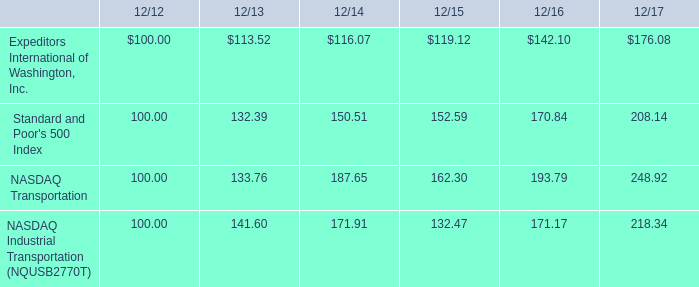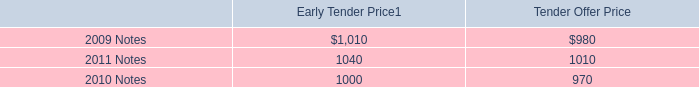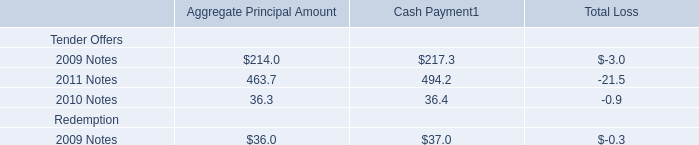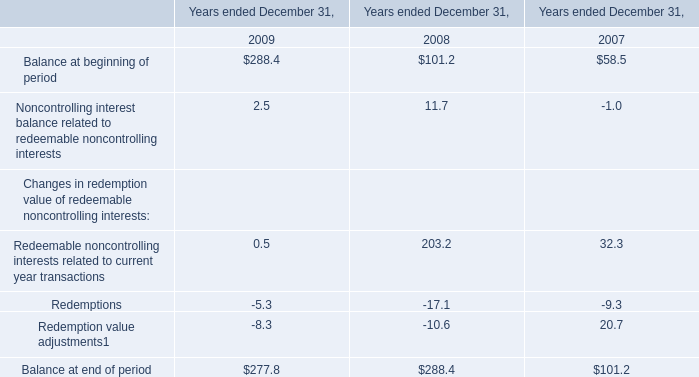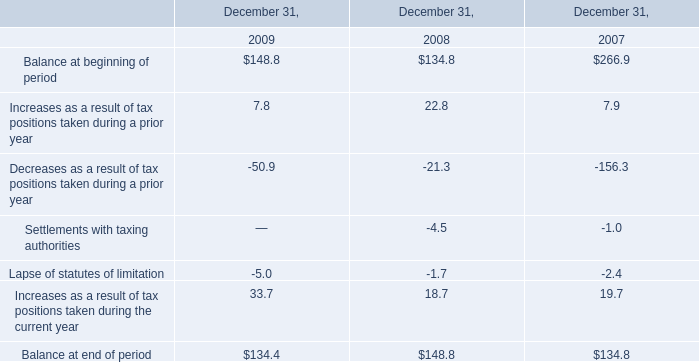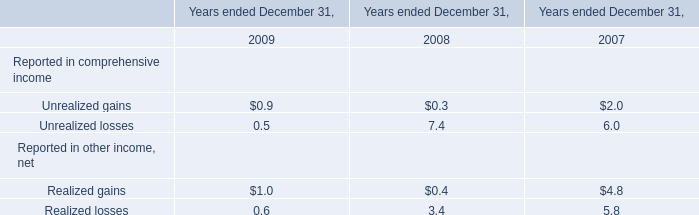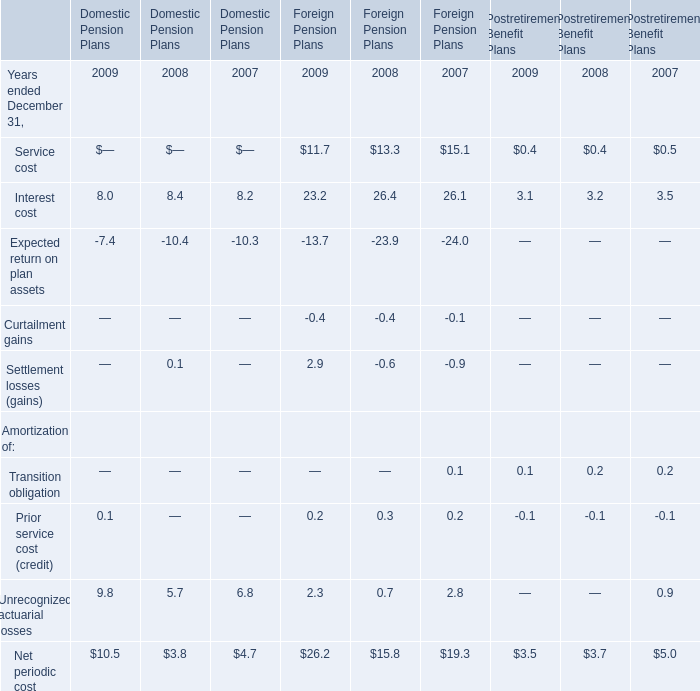What was the total amount of Reported in comprehensive income in 2009? 
Computations: (0.9 + 0.5)
Answer: 1.4. 